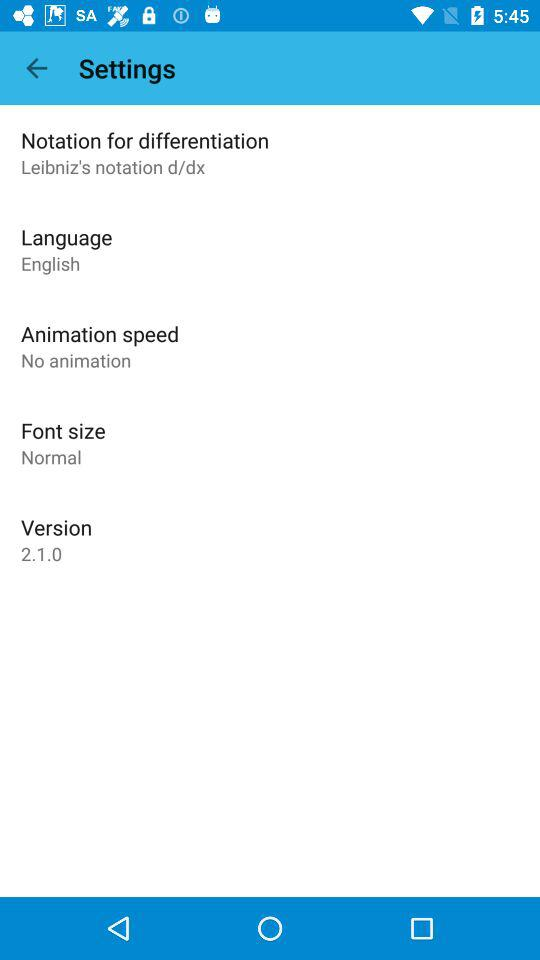What's the font size? The font size is normal. 